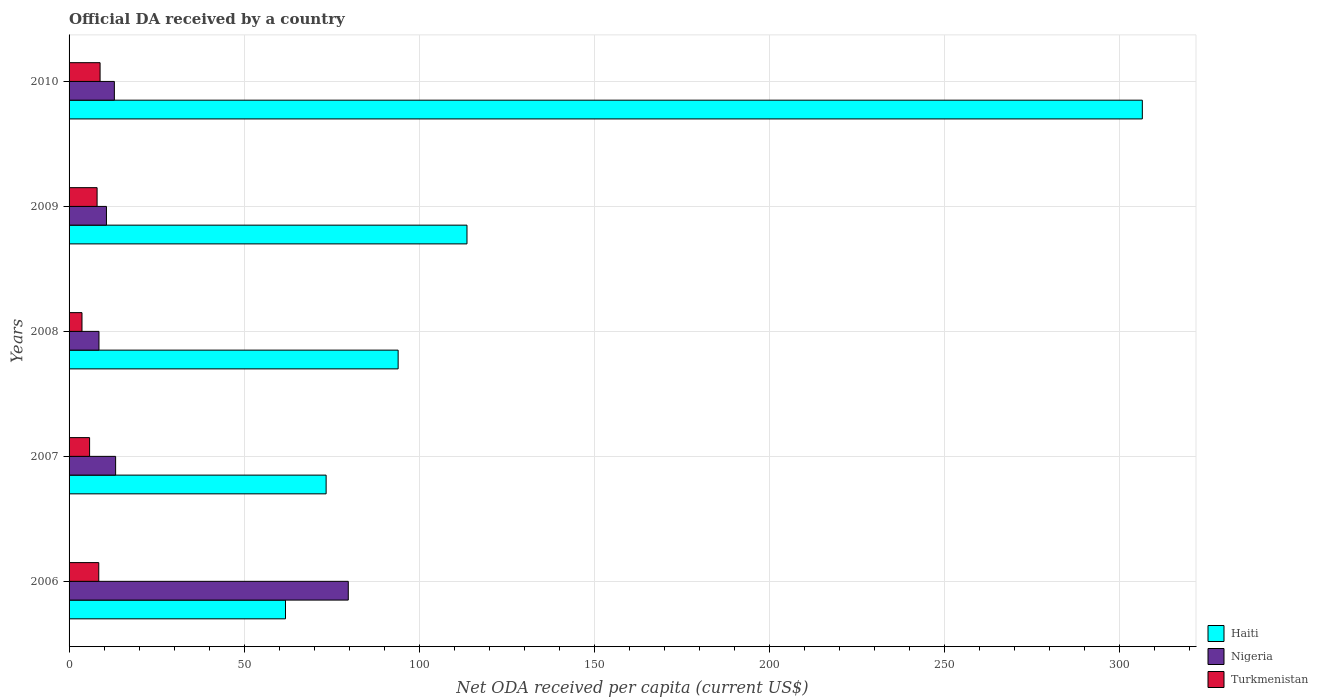Are the number of bars per tick equal to the number of legend labels?
Offer a terse response. Yes. How many bars are there on the 2nd tick from the top?
Your answer should be very brief. 3. How many bars are there on the 4th tick from the bottom?
Ensure brevity in your answer.  3. What is the ODA received in in Haiti in 2008?
Offer a very short reply. 93.98. Across all years, what is the maximum ODA received in in Haiti?
Ensure brevity in your answer.  306.51. Across all years, what is the minimum ODA received in in Nigeria?
Provide a short and direct response. 8.54. In which year was the ODA received in in Nigeria maximum?
Give a very brief answer. 2006. What is the total ODA received in in Turkmenistan in the graph?
Give a very brief answer. 34.88. What is the difference between the ODA received in in Turkmenistan in 2006 and that in 2009?
Give a very brief answer. 0.48. What is the difference between the ODA received in in Nigeria in 2009 and the ODA received in in Haiti in 2008?
Keep it short and to the point. -83.3. What is the average ODA received in in Haiti per year?
Offer a terse response. 129.87. In the year 2009, what is the difference between the ODA received in in Turkmenistan and ODA received in in Haiti?
Offer a terse response. -105.64. What is the ratio of the ODA received in in Turkmenistan in 2006 to that in 2010?
Make the answer very short. 0.96. Is the ODA received in in Turkmenistan in 2006 less than that in 2009?
Offer a very short reply. No. Is the difference between the ODA received in in Turkmenistan in 2009 and 2010 greater than the difference between the ODA received in in Haiti in 2009 and 2010?
Ensure brevity in your answer.  Yes. What is the difference between the highest and the second highest ODA received in in Haiti?
Keep it short and to the point. 192.87. What is the difference between the highest and the lowest ODA received in in Nigeria?
Your response must be concise. 71.2. In how many years, is the ODA received in in Turkmenistan greater than the average ODA received in in Turkmenistan taken over all years?
Your answer should be compact. 3. What does the 3rd bar from the top in 2009 represents?
Your response must be concise. Haiti. What does the 1st bar from the bottom in 2008 represents?
Provide a short and direct response. Haiti. How many years are there in the graph?
Keep it short and to the point. 5. What is the difference between two consecutive major ticks on the X-axis?
Your answer should be compact. 50. Are the values on the major ticks of X-axis written in scientific E-notation?
Your answer should be compact. No. Does the graph contain any zero values?
Your response must be concise. No. Where does the legend appear in the graph?
Your response must be concise. Bottom right. How many legend labels are there?
Your response must be concise. 3. How are the legend labels stacked?
Keep it short and to the point. Vertical. What is the title of the graph?
Make the answer very short. Official DA received by a country. What is the label or title of the X-axis?
Keep it short and to the point. Net ODA received per capita (current US$). What is the Net ODA received per capita (current US$) in Haiti in 2006?
Make the answer very short. 61.81. What is the Net ODA received per capita (current US$) in Nigeria in 2006?
Your response must be concise. 79.74. What is the Net ODA received per capita (current US$) of Turkmenistan in 2006?
Your answer should be very brief. 8.48. What is the Net ODA received per capita (current US$) of Haiti in 2007?
Give a very brief answer. 73.41. What is the Net ODA received per capita (current US$) of Nigeria in 2007?
Offer a very short reply. 13.29. What is the Net ODA received per capita (current US$) of Turkmenistan in 2007?
Give a very brief answer. 5.86. What is the Net ODA received per capita (current US$) in Haiti in 2008?
Your answer should be compact. 93.98. What is the Net ODA received per capita (current US$) in Nigeria in 2008?
Make the answer very short. 8.54. What is the Net ODA received per capita (current US$) in Turkmenistan in 2008?
Give a very brief answer. 3.69. What is the Net ODA received per capita (current US$) in Haiti in 2009?
Keep it short and to the point. 113.64. What is the Net ODA received per capita (current US$) in Nigeria in 2009?
Offer a very short reply. 10.68. What is the Net ODA received per capita (current US$) in Turkmenistan in 2009?
Provide a short and direct response. 8. What is the Net ODA received per capita (current US$) in Haiti in 2010?
Ensure brevity in your answer.  306.51. What is the Net ODA received per capita (current US$) in Nigeria in 2010?
Ensure brevity in your answer.  12.93. What is the Net ODA received per capita (current US$) in Turkmenistan in 2010?
Your response must be concise. 8.86. Across all years, what is the maximum Net ODA received per capita (current US$) of Haiti?
Your response must be concise. 306.51. Across all years, what is the maximum Net ODA received per capita (current US$) of Nigeria?
Keep it short and to the point. 79.74. Across all years, what is the maximum Net ODA received per capita (current US$) in Turkmenistan?
Provide a short and direct response. 8.86. Across all years, what is the minimum Net ODA received per capita (current US$) of Haiti?
Offer a terse response. 61.81. Across all years, what is the minimum Net ODA received per capita (current US$) in Nigeria?
Give a very brief answer. 8.54. Across all years, what is the minimum Net ODA received per capita (current US$) of Turkmenistan?
Offer a very short reply. 3.69. What is the total Net ODA received per capita (current US$) in Haiti in the graph?
Ensure brevity in your answer.  649.34. What is the total Net ODA received per capita (current US$) in Nigeria in the graph?
Offer a terse response. 125.18. What is the total Net ODA received per capita (current US$) of Turkmenistan in the graph?
Give a very brief answer. 34.88. What is the difference between the Net ODA received per capita (current US$) in Haiti in 2006 and that in 2007?
Give a very brief answer. -11.6. What is the difference between the Net ODA received per capita (current US$) of Nigeria in 2006 and that in 2007?
Give a very brief answer. 66.44. What is the difference between the Net ODA received per capita (current US$) of Turkmenistan in 2006 and that in 2007?
Offer a very short reply. 2.62. What is the difference between the Net ODA received per capita (current US$) in Haiti in 2006 and that in 2008?
Make the answer very short. -32.17. What is the difference between the Net ODA received per capita (current US$) of Nigeria in 2006 and that in 2008?
Your answer should be very brief. 71.2. What is the difference between the Net ODA received per capita (current US$) in Turkmenistan in 2006 and that in 2008?
Offer a terse response. 4.79. What is the difference between the Net ODA received per capita (current US$) of Haiti in 2006 and that in 2009?
Make the answer very short. -51.83. What is the difference between the Net ODA received per capita (current US$) in Nigeria in 2006 and that in 2009?
Give a very brief answer. 69.06. What is the difference between the Net ODA received per capita (current US$) in Turkmenistan in 2006 and that in 2009?
Provide a succinct answer. 0.48. What is the difference between the Net ODA received per capita (current US$) in Haiti in 2006 and that in 2010?
Your answer should be compact. -244.7. What is the difference between the Net ODA received per capita (current US$) in Nigeria in 2006 and that in 2010?
Your answer should be very brief. 66.81. What is the difference between the Net ODA received per capita (current US$) of Turkmenistan in 2006 and that in 2010?
Your answer should be compact. -0.38. What is the difference between the Net ODA received per capita (current US$) in Haiti in 2007 and that in 2008?
Ensure brevity in your answer.  -20.57. What is the difference between the Net ODA received per capita (current US$) of Nigeria in 2007 and that in 2008?
Provide a succinct answer. 4.76. What is the difference between the Net ODA received per capita (current US$) of Turkmenistan in 2007 and that in 2008?
Provide a short and direct response. 2.18. What is the difference between the Net ODA received per capita (current US$) of Haiti in 2007 and that in 2009?
Make the answer very short. -40.23. What is the difference between the Net ODA received per capita (current US$) in Nigeria in 2007 and that in 2009?
Make the answer very short. 2.62. What is the difference between the Net ODA received per capita (current US$) of Turkmenistan in 2007 and that in 2009?
Give a very brief answer. -2.14. What is the difference between the Net ODA received per capita (current US$) in Haiti in 2007 and that in 2010?
Give a very brief answer. -233.1. What is the difference between the Net ODA received per capita (current US$) in Nigeria in 2007 and that in 2010?
Your answer should be very brief. 0.36. What is the difference between the Net ODA received per capita (current US$) of Turkmenistan in 2007 and that in 2010?
Your answer should be compact. -2.99. What is the difference between the Net ODA received per capita (current US$) of Haiti in 2008 and that in 2009?
Offer a very short reply. -19.66. What is the difference between the Net ODA received per capita (current US$) in Nigeria in 2008 and that in 2009?
Provide a short and direct response. -2.14. What is the difference between the Net ODA received per capita (current US$) of Turkmenistan in 2008 and that in 2009?
Give a very brief answer. -4.31. What is the difference between the Net ODA received per capita (current US$) in Haiti in 2008 and that in 2010?
Your answer should be compact. -212.53. What is the difference between the Net ODA received per capita (current US$) of Nigeria in 2008 and that in 2010?
Provide a short and direct response. -4.4. What is the difference between the Net ODA received per capita (current US$) of Turkmenistan in 2008 and that in 2010?
Your answer should be very brief. -5.17. What is the difference between the Net ODA received per capita (current US$) of Haiti in 2009 and that in 2010?
Offer a very short reply. -192.87. What is the difference between the Net ODA received per capita (current US$) in Nigeria in 2009 and that in 2010?
Your response must be concise. -2.26. What is the difference between the Net ODA received per capita (current US$) in Turkmenistan in 2009 and that in 2010?
Make the answer very short. -0.85. What is the difference between the Net ODA received per capita (current US$) in Haiti in 2006 and the Net ODA received per capita (current US$) in Nigeria in 2007?
Offer a terse response. 48.52. What is the difference between the Net ODA received per capita (current US$) in Haiti in 2006 and the Net ODA received per capita (current US$) in Turkmenistan in 2007?
Your response must be concise. 55.95. What is the difference between the Net ODA received per capita (current US$) in Nigeria in 2006 and the Net ODA received per capita (current US$) in Turkmenistan in 2007?
Keep it short and to the point. 73.88. What is the difference between the Net ODA received per capita (current US$) of Haiti in 2006 and the Net ODA received per capita (current US$) of Nigeria in 2008?
Your answer should be very brief. 53.27. What is the difference between the Net ODA received per capita (current US$) of Haiti in 2006 and the Net ODA received per capita (current US$) of Turkmenistan in 2008?
Offer a terse response. 58.12. What is the difference between the Net ODA received per capita (current US$) of Nigeria in 2006 and the Net ODA received per capita (current US$) of Turkmenistan in 2008?
Ensure brevity in your answer.  76.05. What is the difference between the Net ODA received per capita (current US$) of Haiti in 2006 and the Net ODA received per capita (current US$) of Nigeria in 2009?
Keep it short and to the point. 51.13. What is the difference between the Net ODA received per capita (current US$) of Haiti in 2006 and the Net ODA received per capita (current US$) of Turkmenistan in 2009?
Your answer should be compact. 53.81. What is the difference between the Net ODA received per capita (current US$) of Nigeria in 2006 and the Net ODA received per capita (current US$) of Turkmenistan in 2009?
Keep it short and to the point. 71.74. What is the difference between the Net ODA received per capita (current US$) in Haiti in 2006 and the Net ODA received per capita (current US$) in Nigeria in 2010?
Offer a terse response. 48.88. What is the difference between the Net ODA received per capita (current US$) of Haiti in 2006 and the Net ODA received per capita (current US$) of Turkmenistan in 2010?
Offer a very short reply. 52.95. What is the difference between the Net ODA received per capita (current US$) in Nigeria in 2006 and the Net ODA received per capita (current US$) in Turkmenistan in 2010?
Ensure brevity in your answer.  70.88. What is the difference between the Net ODA received per capita (current US$) of Haiti in 2007 and the Net ODA received per capita (current US$) of Nigeria in 2008?
Your answer should be very brief. 64.87. What is the difference between the Net ODA received per capita (current US$) in Haiti in 2007 and the Net ODA received per capita (current US$) in Turkmenistan in 2008?
Keep it short and to the point. 69.72. What is the difference between the Net ODA received per capita (current US$) in Nigeria in 2007 and the Net ODA received per capita (current US$) in Turkmenistan in 2008?
Provide a short and direct response. 9.61. What is the difference between the Net ODA received per capita (current US$) of Haiti in 2007 and the Net ODA received per capita (current US$) of Nigeria in 2009?
Your answer should be very brief. 62.73. What is the difference between the Net ODA received per capita (current US$) in Haiti in 2007 and the Net ODA received per capita (current US$) in Turkmenistan in 2009?
Ensure brevity in your answer.  65.41. What is the difference between the Net ODA received per capita (current US$) of Nigeria in 2007 and the Net ODA received per capita (current US$) of Turkmenistan in 2009?
Provide a short and direct response. 5.29. What is the difference between the Net ODA received per capita (current US$) of Haiti in 2007 and the Net ODA received per capita (current US$) of Nigeria in 2010?
Offer a terse response. 60.48. What is the difference between the Net ODA received per capita (current US$) in Haiti in 2007 and the Net ODA received per capita (current US$) in Turkmenistan in 2010?
Your answer should be very brief. 64.56. What is the difference between the Net ODA received per capita (current US$) in Nigeria in 2007 and the Net ODA received per capita (current US$) in Turkmenistan in 2010?
Provide a short and direct response. 4.44. What is the difference between the Net ODA received per capita (current US$) in Haiti in 2008 and the Net ODA received per capita (current US$) in Nigeria in 2009?
Ensure brevity in your answer.  83.3. What is the difference between the Net ODA received per capita (current US$) of Haiti in 2008 and the Net ODA received per capita (current US$) of Turkmenistan in 2009?
Your answer should be very brief. 85.98. What is the difference between the Net ODA received per capita (current US$) in Nigeria in 2008 and the Net ODA received per capita (current US$) in Turkmenistan in 2009?
Your answer should be very brief. 0.54. What is the difference between the Net ODA received per capita (current US$) of Haiti in 2008 and the Net ODA received per capita (current US$) of Nigeria in 2010?
Provide a succinct answer. 81.04. What is the difference between the Net ODA received per capita (current US$) of Haiti in 2008 and the Net ODA received per capita (current US$) of Turkmenistan in 2010?
Ensure brevity in your answer.  85.12. What is the difference between the Net ODA received per capita (current US$) in Nigeria in 2008 and the Net ODA received per capita (current US$) in Turkmenistan in 2010?
Make the answer very short. -0.32. What is the difference between the Net ODA received per capita (current US$) in Haiti in 2009 and the Net ODA received per capita (current US$) in Nigeria in 2010?
Your answer should be compact. 100.7. What is the difference between the Net ODA received per capita (current US$) in Haiti in 2009 and the Net ODA received per capita (current US$) in Turkmenistan in 2010?
Offer a very short reply. 104.78. What is the difference between the Net ODA received per capita (current US$) of Nigeria in 2009 and the Net ODA received per capita (current US$) of Turkmenistan in 2010?
Your answer should be compact. 1.82. What is the average Net ODA received per capita (current US$) in Haiti per year?
Your answer should be compact. 129.87. What is the average Net ODA received per capita (current US$) in Nigeria per year?
Offer a very short reply. 25.04. What is the average Net ODA received per capita (current US$) of Turkmenistan per year?
Offer a terse response. 6.98. In the year 2006, what is the difference between the Net ODA received per capita (current US$) in Haiti and Net ODA received per capita (current US$) in Nigeria?
Ensure brevity in your answer.  -17.93. In the year 2006, what is the difference between the Net ODA received per capita (current US$) of Haiti and Net ODA received per capita (current US$) of Turkmenistan?
Provide a short and direct response. 53.33. In the year 2006, what is the difference between the Net ODA received per capita (current US$) in Nigeria and Net ODA received per capita (current US$) in Turkmenistan?
Provide a short and direct response. 71.26. In the year 2007, what is the difference between the Net ODA received per capita (current US$) in Haiti and Net ODA received per capita (current US$) in Nigeria?
Provide a succinct answer. 60.12. In the year 2007, what is the difference between the Net ODA received per capita (current US$) of Haiti and Net ODA received per capita (current US$) of Turkmenistan?
Keep it short and to the point. 67.55. In the year 2007, what is the difference between the Net ODA received per capita (current US$) of Nigeria and Net ODA received per capita (current US$) of Turkmenistan?
Provide a succinct answer. 7.43. In the year 2008, what is the difference between the Net ODA received per capita (current US$) in Haiti and Net ODA received per capita (current US$) in Nigeria?
Provide a succinct answer. 85.44. In the year 2008, what is the difference between the Net ODA received per capita (current US$) in Haiti and Net ODA received per capita (current US$) in Turkmenistan?
Provide a succinct answer. 90.29. In the year 2008, what is the difference between the Net ODA received per capita (current US$) of Nigeria and Net ODA received per capita (current US$) of Turkmenistan?
Ensure brevity in your answer.  4.85. In the year 2009, what is the difference between the Net ODA received per capita (current US$) in Haiti and Net ODA received per capita (current US$) in Nigeria?
Ensure brevity in your answer.  102.96. In the year 2009, what is the difference between the Net ODA received per capita (current US$) of Haiti and Net ODA received per capita (current US$) of Turkmenistan?
Your answer should be very brief. 105.64. In the year 2009, what is the difference between the Net ODA received per capita (current US$) of Nigeria and Net ODA received per capita (current US$) of Turkmenistan?
Provide a succinct answer. 2.67. In the year 2010, what is the difference between the Net ODA received per capita (current US$) of Haiti and Net ODA received per capita (current US$) of Nigeria?
Make the answer very short. 293.57. In the year 2010, what is the difference between the Net ODA received per capita (current US$) in Haiti and Net ODA received per capita (current US$) in Turkmenistan?
Provide a short and direct response. 297.65. In the year 2010, what is the difference between the Net ODA received per capita (current US$) of Nigeria and Net ODA received per capita (current US$) of Turkmenistan?
Provide a succinct answer. 4.08. What is the ratio of the Net ODA received per capita (current US$) in Haiti in 2006 to that in 2007?
Offer a very short reply. 0.84. What is the ratio of the Net ODA received per capita (current US$) in Nigeria in 2006 to that in 2007?
Provide a short and direct response. 6. What is the ratio of the Net ODA received per capita (current US$) in Turkmenistan in 2006 to that in 2007?
Make the answer very short. 1.45. What is the ratio of the Net ODA received per capita (current US$) in Haiti in 2006 to that in 2008?
Offer a very short reply. 0.66. What is the ratio of the Net ODA received per capita (current US$) in Nigeria in 2006 to that in 2008?
Your answer should be very brief. 9.34. What is the ratio of the Net ODA received per capita (current US$) in Turkmenistan in 2006 to that in 2008?
Your response must be concise. 2.3. What is the ratio of the Net ODA received per capita (current US$) of Haiti in 2006 to that in 2009?
Provide a short and direct response. 0.54. What is the ratio of the Net ODA received per capita (current US$) in Nigeria in 2006 to that in 2009?
Your answer should be compact. 7.47. What is the ratio of the Net ODA received per capita (current US$) in Turkmenistan in 2006 to that in 2009?
Keep it short and to the point. 1.06. What is the ratio of the Net ODA received per capita (current US$) in Haiti in 2006 to that in 2010?
Make the answer very short. 0.2. What is the ratio of the Net ODA received per capita (current US$) of Nigeria in 2006 to that in 2010?
Ensure brevity in your answer.  6.17. What is the ratio of the Net ODA received per capita (current US$) in Turkmenistan in 2006 to that in 2010?
Your answer should be very brief. 0.96. What is the ratio of the Net ODA received per capita (current US$) in Haiti in 2007 to that in 2008?
Give a very brief answer. 0.78. What is the ratio of the Net ODA received per capita (current US$) of Nigeria in 2007 to that in 2008?
Your answer should be compact. 1.56. What is the ratio of the Net ODA received per capita (current US$) in Turkmenistan in 2007 to that in 2008?
Make the answer very short. 1.59. What is the ratio of the Net ODA received per capita (current US$) in Haiti in 2007 to that in 2009?
Ensure brevity in your answer.  0.65. What is the ratio of the Net ODA received per capita (current US$) in Nigeria in 2007 to that in 2009?
Provide a short and direct response. 1.25. What is the ratio of the Net ODA received per capita (current US$) in Turkmenistan in 2007 to that in 2009?
Your answer should be compact. 0.73. What is the ratio of the Net ODA received per capita (current US$) in Haiti in 2007 to that in 2010?
Give a very brief answer. 0.24. What is the ratio of the Net ODA received per capita (current US$) in Nigeria in 2007 to that in 2010?
Your answer should be compact. 1.03. What is the ratio of the Net ODA received per capita (current US$) of Turkmenistan in 2007 to that in 2010?
Offer a very short reply. 0.66. What is the ratio of the Net ODA received per capita (current US$) in Haiti in 2008 to that in 2009?
Keep it short and to the point. 0.83. What is the ratio of the Net ODA received per capita (current US$) of Nigeria in 2008 to that in 2009?
Make the answer very short. 0.8. What is the ratio of the Net ODA received per capita (current US$) of Turkmenistan in 2008 to that in 2009?
Your answer should be compact. 0.46. What is the ratio of the Net ODA received per capita (current US$) of Haiti in 2008 to that in 2010?
Your response must be concise. 0.31. What is the ratio of the Net ODA received per capita (current US$) in Nigeria in 2008 to that in 2010?
Provide a succinct answer. 0.66. What is the ratio of the Net ODA received per capita (current US$) of Turkmenistan in 2008 to that in 2010?
Offer a very short reply. 0.42. What is the ratio of the Net ODA received per capita (current US$) in Haiti in 2009 to that in 2010?
Offer a very short reply. 0.37. What is the ratio of the Net ODA received per capita (current US$) in Nigeria in 2009 to that in 2010?
Your response must be concise. 0.83. What is the ratio of the Net ODA received per capita (current US$) of Turkmenistan in 2009 to that in 2010?
Your answer should be compact. 0.9. What is the difference between the highest and the second highest Net ODA received per capita (current US$) of Haiti?
Your answer should be very brief. 192.87. What is the difference between the highest and the second highest Net ODA received per capita (current US$) of Nigeria?
Offer a very short reply. 66.44. What is the difference between the highest and the second highest Net ODA received per capita (current US$) of Turkmenistan?
Your answer should be very brief. 0.38. What is the difference between the highest and the lowest Net ODA received per capita (current US$) of Haiti?
Make the answer very short. 244.7. What is the difference between the highest and the lowest Net ODA received per capita (current US$) of Nigeria?
Give a very brief answer. 71.2. What is the difference between the highest and the lowest Net ODA received per capita (current US$) of Turkmenistan?
Your response must be concise. 5.17. 